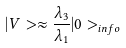Convert formula to latex. <formula><loc_0><loc_0><loc_500><loc_500>| V > \approx \frac { \lambda _ { 3 } } { \lambda _ { 1 } } | 0 > _ { i n f o }</formula> 